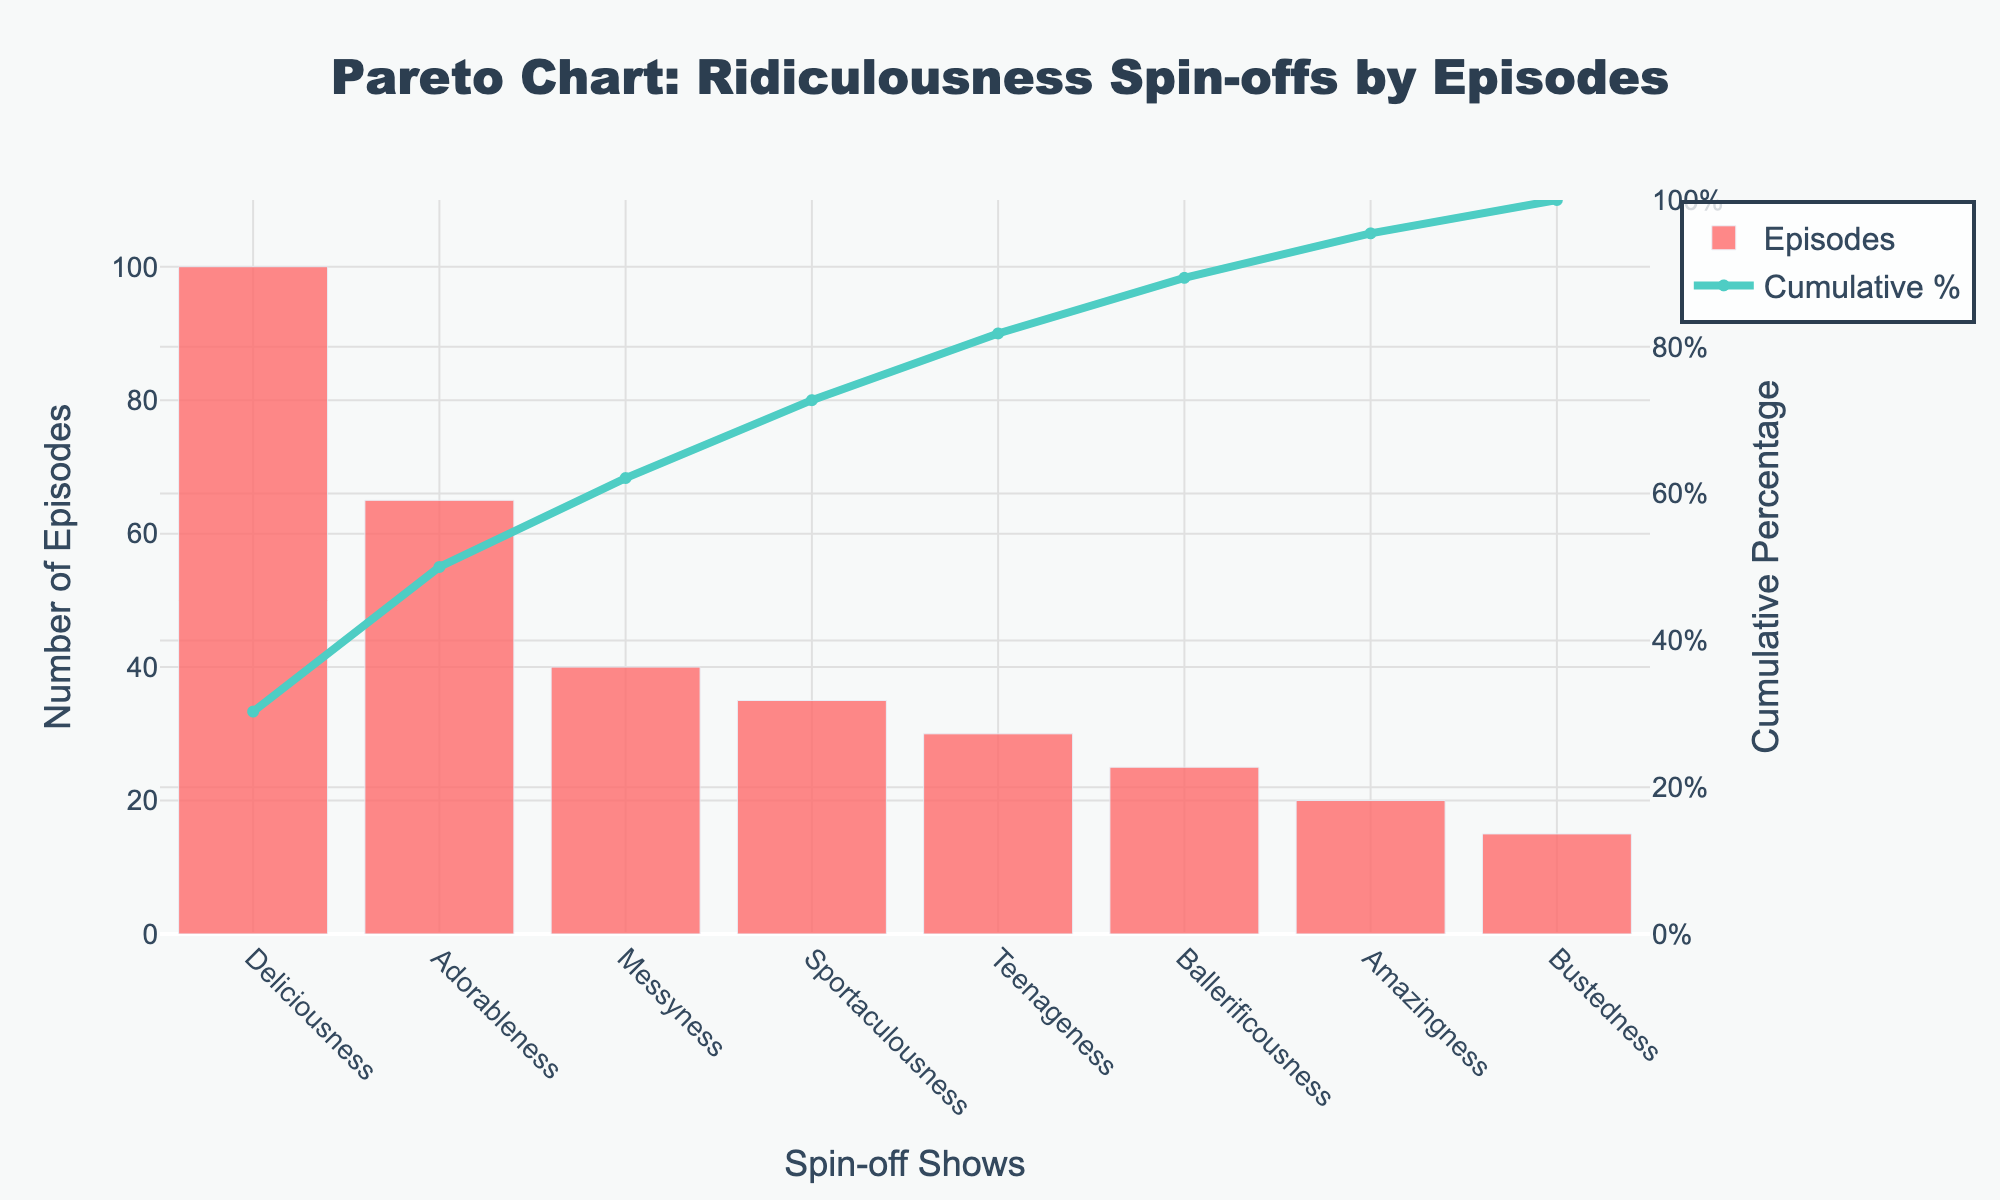Which spin-off show has the highest number of episodes? By looking at the bar chart, the tallest bar represents the spin-off with the highest number of episodes. The tallest bar corresponds to "Deliciousness".
Answer: Deliciousness What is the cumulative percentage of episodes after "Adorableness"? After "Adorableness," the cumulative percentage can be found by looking at the line graph where it aligns with the "Adorableness" bar. This value is approximately 40%.
Answer: 40% How many episodes do the bottom three spin-offs have in total? Adding the number of episodes for the bottom three spin-offs: "Amazingness" (20), "Bustedness" (15), and "Ballerificousness" (25) gives a total of 20 + 15 + 25 = 60 episodes.
Answer: 60 What is the difference in the number of episodes between "Messyness" and "Sportaculousness"? The number of episodes for "Messyness" is 40 and for "Sportaculousness" is 35. The difference is 40 - 35 = 5 episodes.
Answer: 5 How many spin-offs have fewer than 50 episodes? By scanning the bar chart, the spin-offs with fewer than 50 episodes are "Messyness" (40), "Sportaculousness" (35), "Teenageness" (30), "Ballerificousness" (25), "Amazingness" (20), and "Bustedness" (15). There are 6 such spin-offs.
Answer: 6 What is the cumulative percentage of episodes for the first four spin-offs? The first four spin-offs are "Deliciousness," "Adorableness," "Messyness," and "Sportaculousness." The cumulative percentage aligns with "Sportaculousness" on the line graph, which is approximately 87%.
Answer: 87% Which spin-off contributes around 30% to the cumulative total of episodes? By observing the line graph, the spin-off that contributes around 30% is "Adorableness."
Answer: Adorableness Is the cumulative percentage of episodes for "Teenageness" greater than 75%? By looking at the line graph, the cumulative percentage for "Teenageness" is approximately 90%, which is greater than 75%.
Answer: Yes 